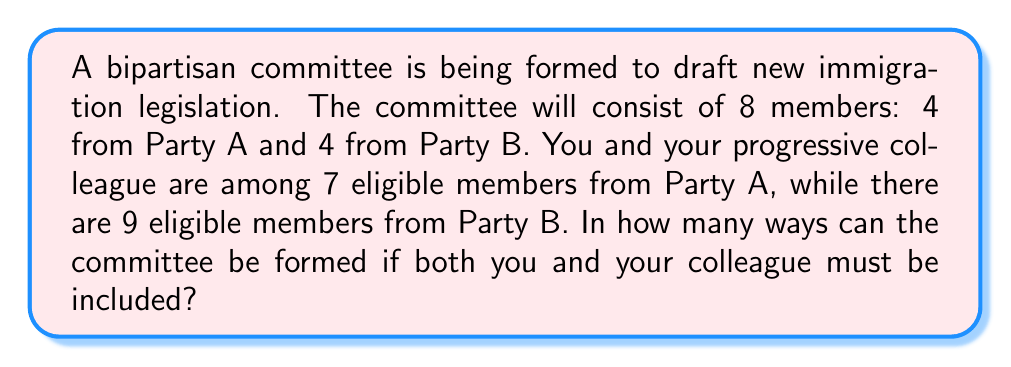Teach me how to tackle this problem. Let's approach this step-by-step:

1) You and your colleague must be included, so 2 of the 4 spots for Party A are already filled.

2) We need to choose 2 more members from Party A:
   - There are 5 remaining eligible members from Party A (7 total - 2 already selected)
   - We need to choose 2 from these 5
   - This can be done in $\binom{5}{2}$ ways

3) Calculate $\binom{5}{2}$:
   $$\binom{5}{2} = \frac{5!}{2!(5-2)!} = \frac{5 \cdot 4}{2 \cdot 1} = 10$$

4) For Party B, we need to choose 4 members from 9 eligible members:
   - This can be done in $\binom{9}{4}$ ways

5) Calculate $\binom{9}{4}$:
   $$\binom{9}{4} = \frac{9!}{4!(9-4)!} = \frac{9 \cdot 8 \cdot 7 \cdot 6}{4 \cdot 3 \cdot 2 \cdot 1} = 126$$

6) By the multiplication principle, the total number of ways to form the committee is:
   $$10 \cdot 126 = 1260$$

Therefore, there are 1260 possible committee configurations.
Answer: 1260 